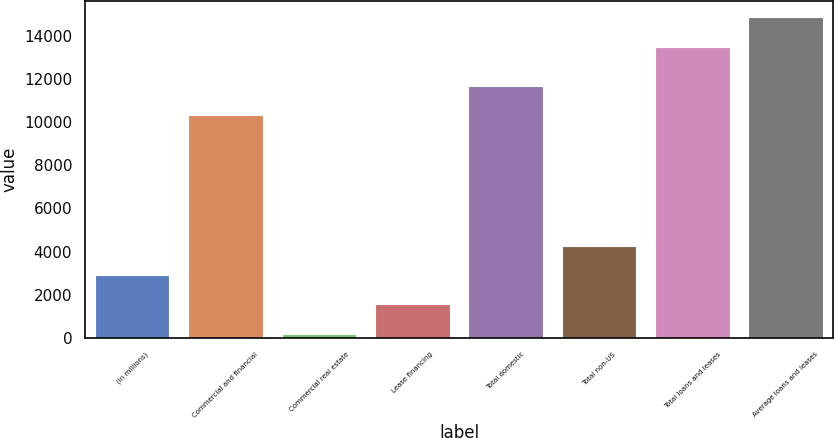Convert chart to OTSL. <chart><loc_0><loc_0><loc_500><loc_500><bar_chart><fcel>(In millions)<fcel>Commercial and financial<fcel>Commercial real estate<fcel>Lease financing<fcel>Total domestic<fcel>Total non-US<fcel>Total loans and leases<fcel>Average loans and leases<nl><fcel>2923.4<fcel>10305<fcel>209<fcel>1566.2<fcel>11662.2<fcel>4280.6<fcel>13486<fcel>14843.2<nl></chart> 